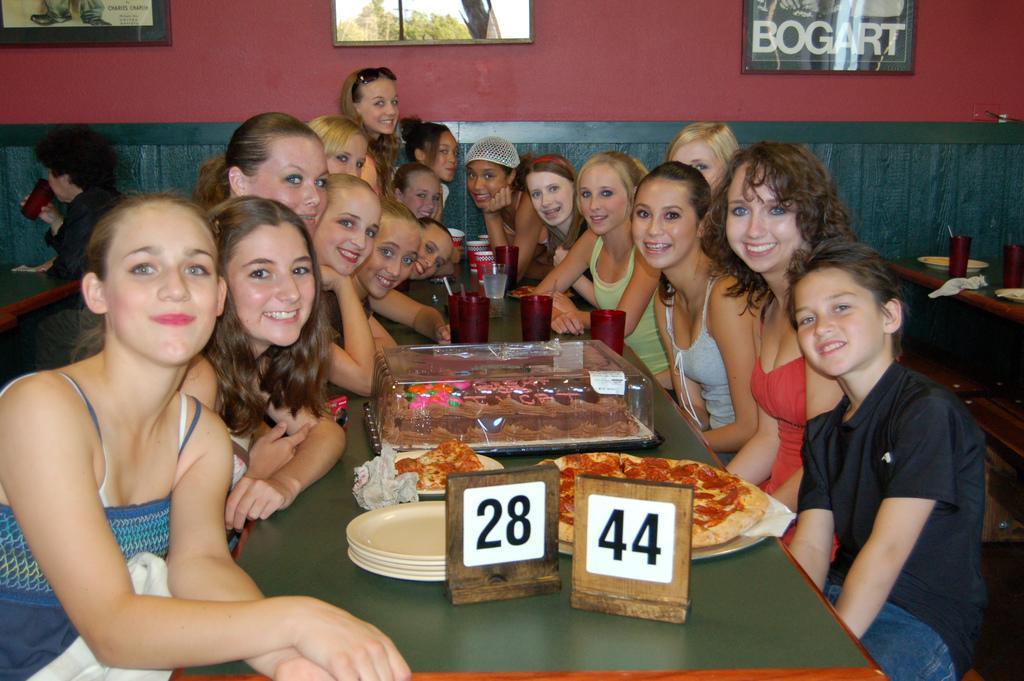How would you summarize this image in a sentence or two? Persons are sitting on the bench and on the table we have plate,food and in the back there is wall with photo frames. 